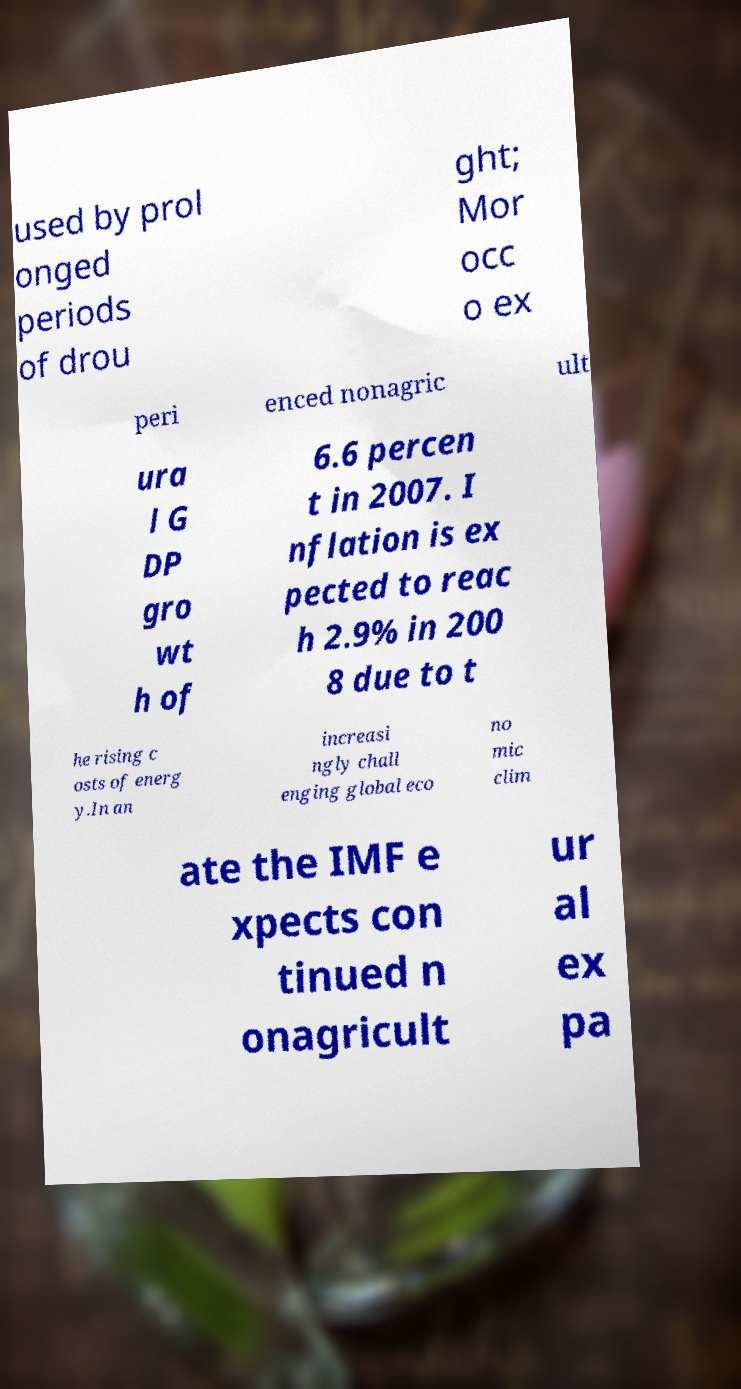There's text embedded in this image that I need extracted. Can you transcribe it verbatim? used by prol onged periods of drou ght; Mor occ o ex peri enced nonagric ult ura l G DP gro wt h of 6.6 percen t in 2007. I nflation is ex pected to reac h 2.9% in 200 8 due to t he rising c osts of energ y.In an increasi ngly chall enging global eco no mic clim ate the IMF e xpects con tinued n onagricult ur al ex pa 